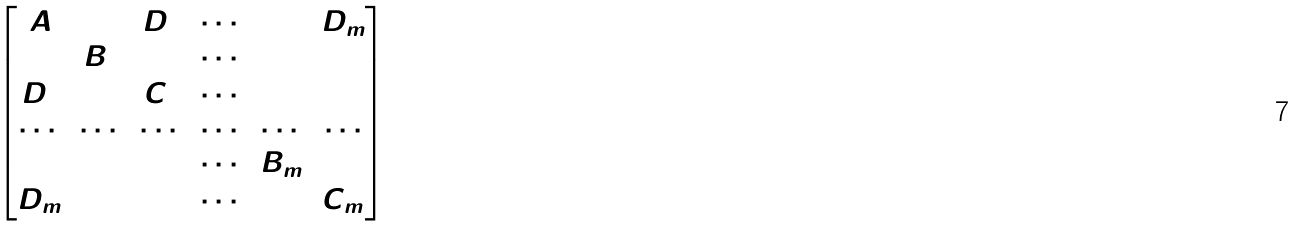<formula> <loc_0><loc_0><loc_500><loc_500>\begin{bmatrix} A & 0 & D _ { 1 } & \cdots & 0 & D _ { m } \\ 0 & B _ { 1 } & 0 & \cdots & 0 & 0 \\ \bar { D } _ { 1 } & 0 & C _ { 1 } & \cdots & 0 & 0 \\ \cdots & \cdots & \cdots & \cdots & \cdots & \cdots \\ 0 & 0 & 0 & \cdots & B _ { m } & 0 \\ \bar { D } _ { m } & 0 & 0 & \cdots & 0 & C _ { m } \\ \end{bmatrix}</formula> 